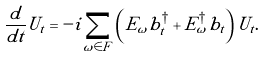Convert formula to latex. <formula><loc_0><loc_0><loc_500><loc_500>\frac { d } { d t } U _ { t } = - i \sum _ { \omega \in F } \left ( E _ { \omega } b ^ { \dagger } _ { t } + E ^ { \dagger } _ { \omega } b _ { t } \right ) U _ { t } .</formula> 